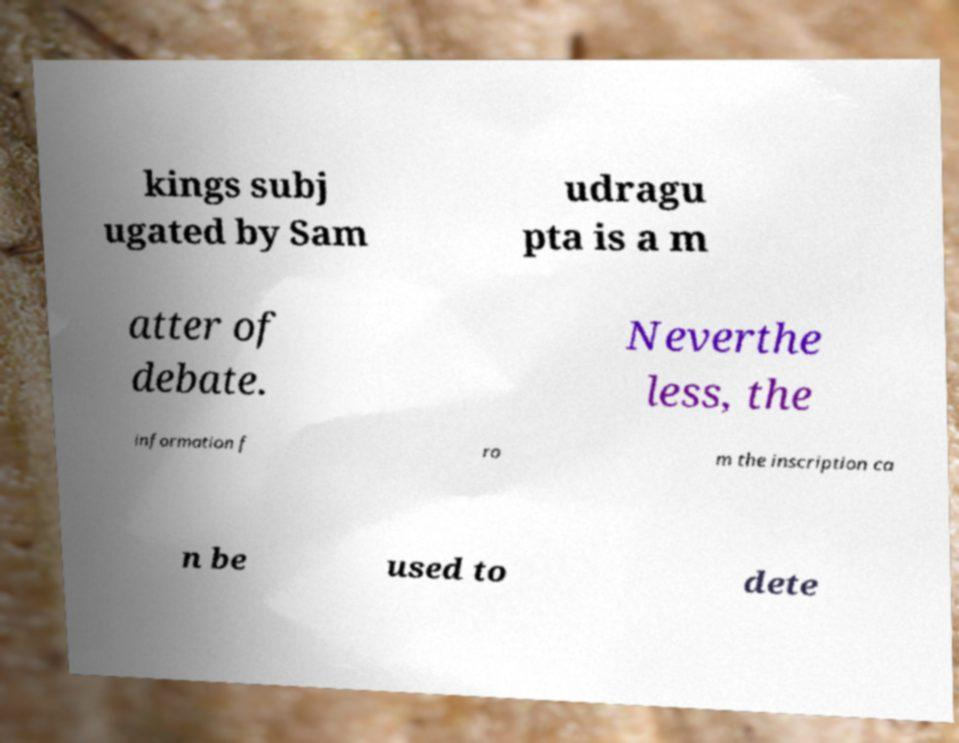Please identify and transcribe the text found in this image. kings subj ugated by Sam udragu pta is a m atter of debate. Neverthe less, the information f ro m the inscription ca n be used to dete 